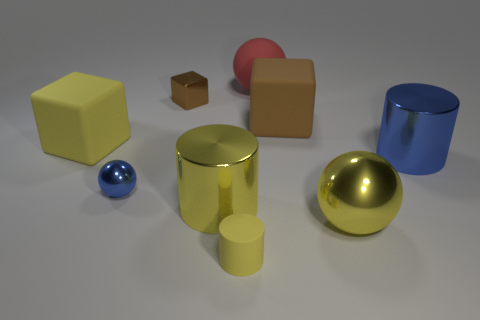Subtract all tiny yellow cylinders. How many cylinders are left? 2 Add 7 big red objects. How many big red objects are left? 8 Add 7 matte spheres. How many matte spheres exist? 8 Add 1 small cyan objects. How many objects exist? 10 Subtract all brown cubes. How many cubes are left? 1 Subtract 0 brown balls. How many objects are left? 9 Subtract all cylinders. How many objects are left? 6 Subtract 2 cylinders. How many cylinders are left? 1 Subtract all yellow cubes. Subtract all red cylinders. How many cubes are left? 2 Subtract all red cylinders. How many purple spheres are left? 0 